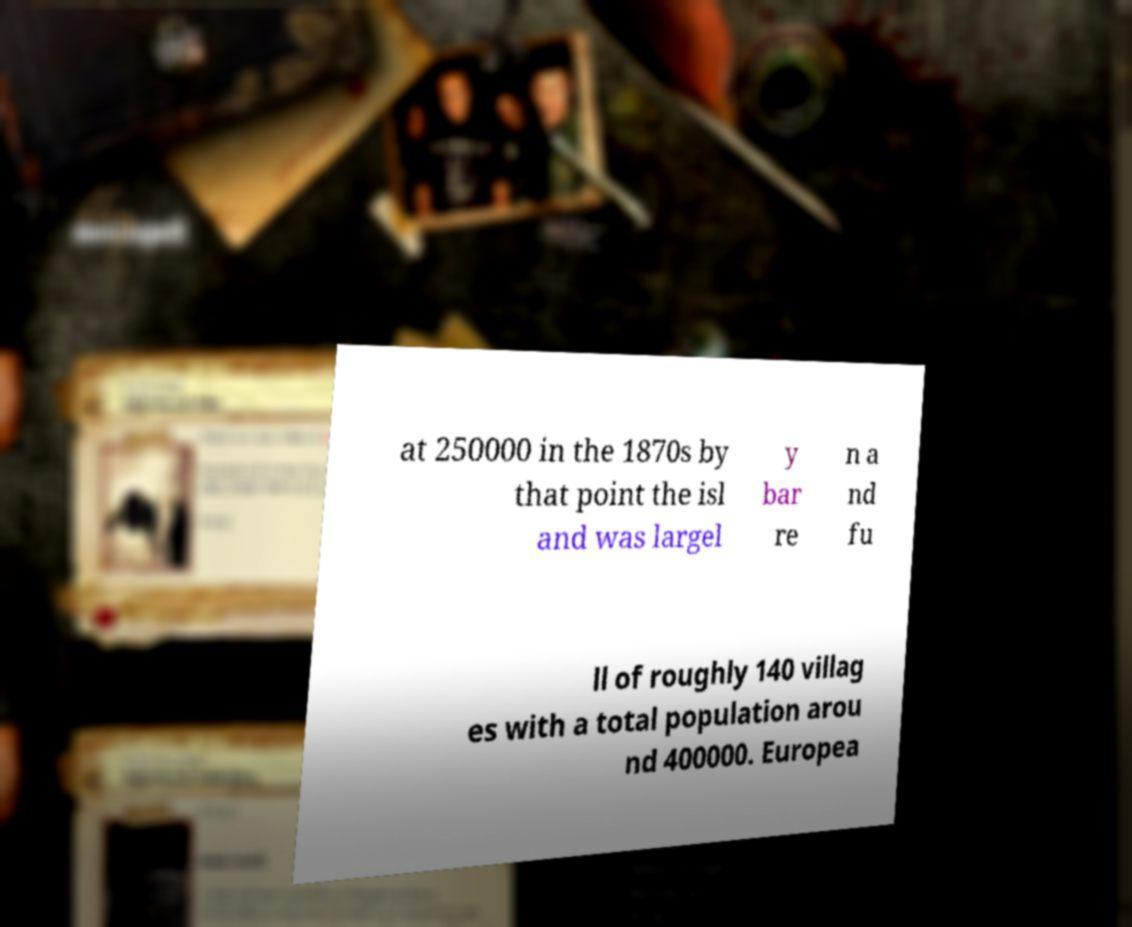Please identify and transcribe the text found in this image. at 250000 in the 1870s by that point the isl and was largel y bar re n a nd fu ll of roughly 140 villag es with a total population arou nd 400000. Europea 